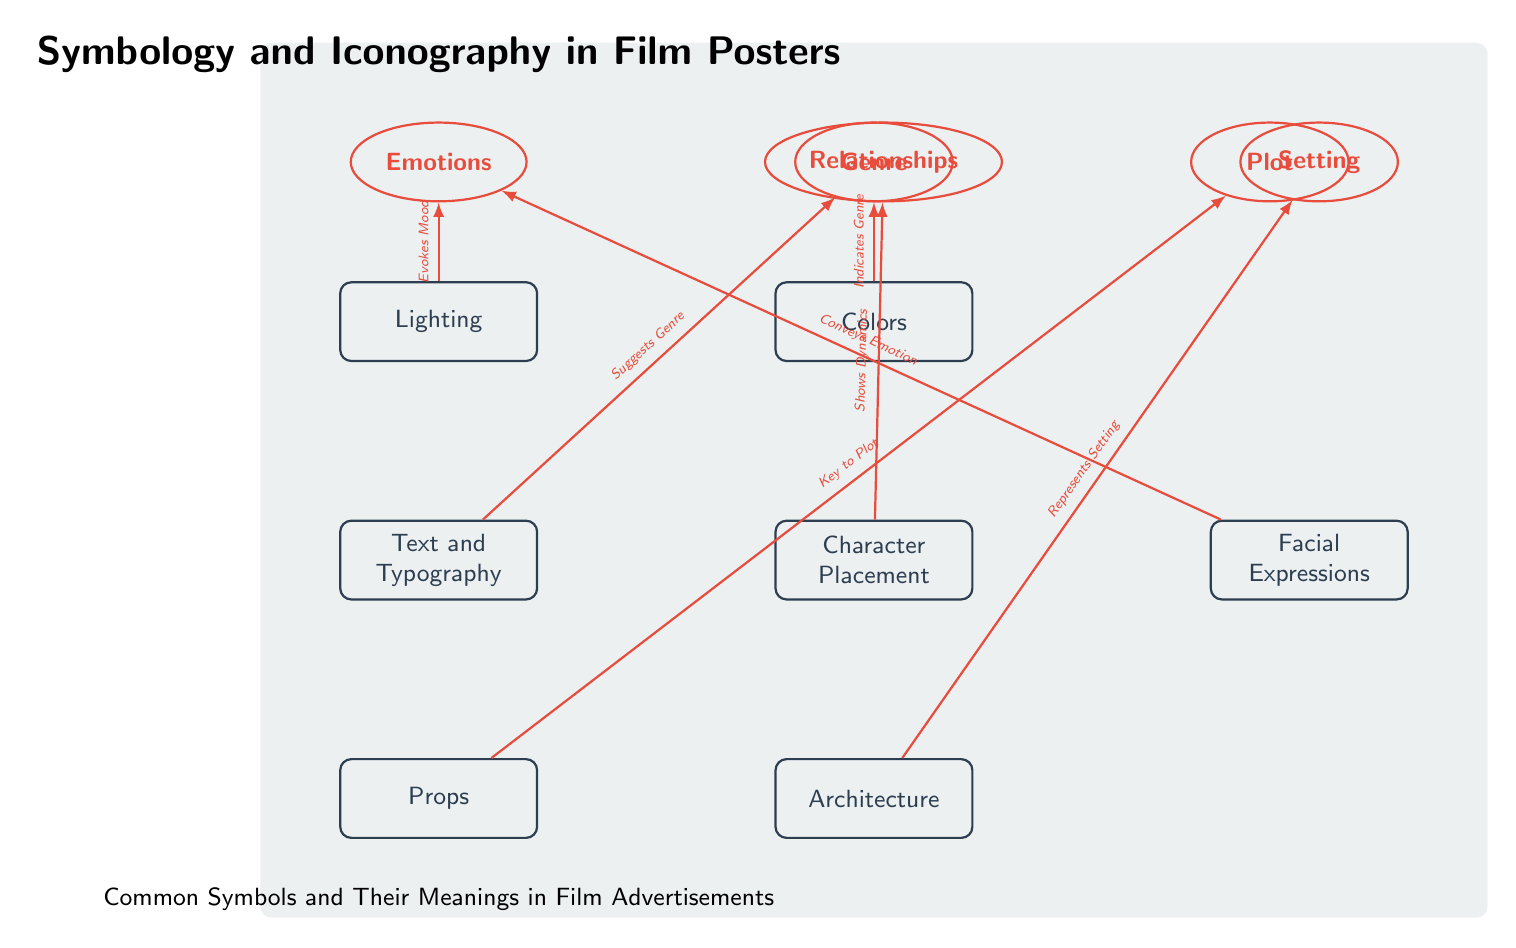What is the title of the diagram? The title of the diagram is displayed at the top, stating "Symbology and Iconography in Film Posters."
Answer: Symbology and Iconography in Film Posters How many main symbols are shown in the diagram? The diagram displays a total of 6 main symbols listed vertically. They include Lighting, Colors, Text and Typography, Character Placement, Props, and Architecture.
Answer: 6 What symbol indicates genre? The symbol that indicates genre is the "Colors" symbol, as implied by the connection in the diagram.
Answer: Colors What relationship does "Lighting" have with "Emotions"? "Lighting" is connected to "Emotions" with an arrow labeled "Evokes Mood," reflecting its influence on emotional perception.
Answer: Evokes Mood Which symbol suggests the genre of the film? The symbols "Text and Typography" and "Colors" both are shown to suggest the genre through their connections to the "Genre" node.
Answer: Text and Typography, Colors What role do "Facial Expressions" play in the diagram? "Facial Expressions" convey emotion as indicated by the directed edge that connects it to the "Emotions" node, labeled accordingly.
Answer: Conveys Emotion What does "Props" symbolize in the context of the diagram? The "Props" symbol is labeled with a directed edge leading to "Plot," indicating its function as key to the narrative.
Answer: Key to Plot How do "Characters" relate to "Relationships"? "Characters" shows dynamics in relationships, which is expressed through the directed edge leading to the "Relationships" node.
Answer: Shows Dynamics What does the "Architecture" symbol represent? The diagram specifies that the "Architecture" symbol represents the setting in the film, as shown by its directed edge to the "Setting" node.
Answer: Represents Setting 